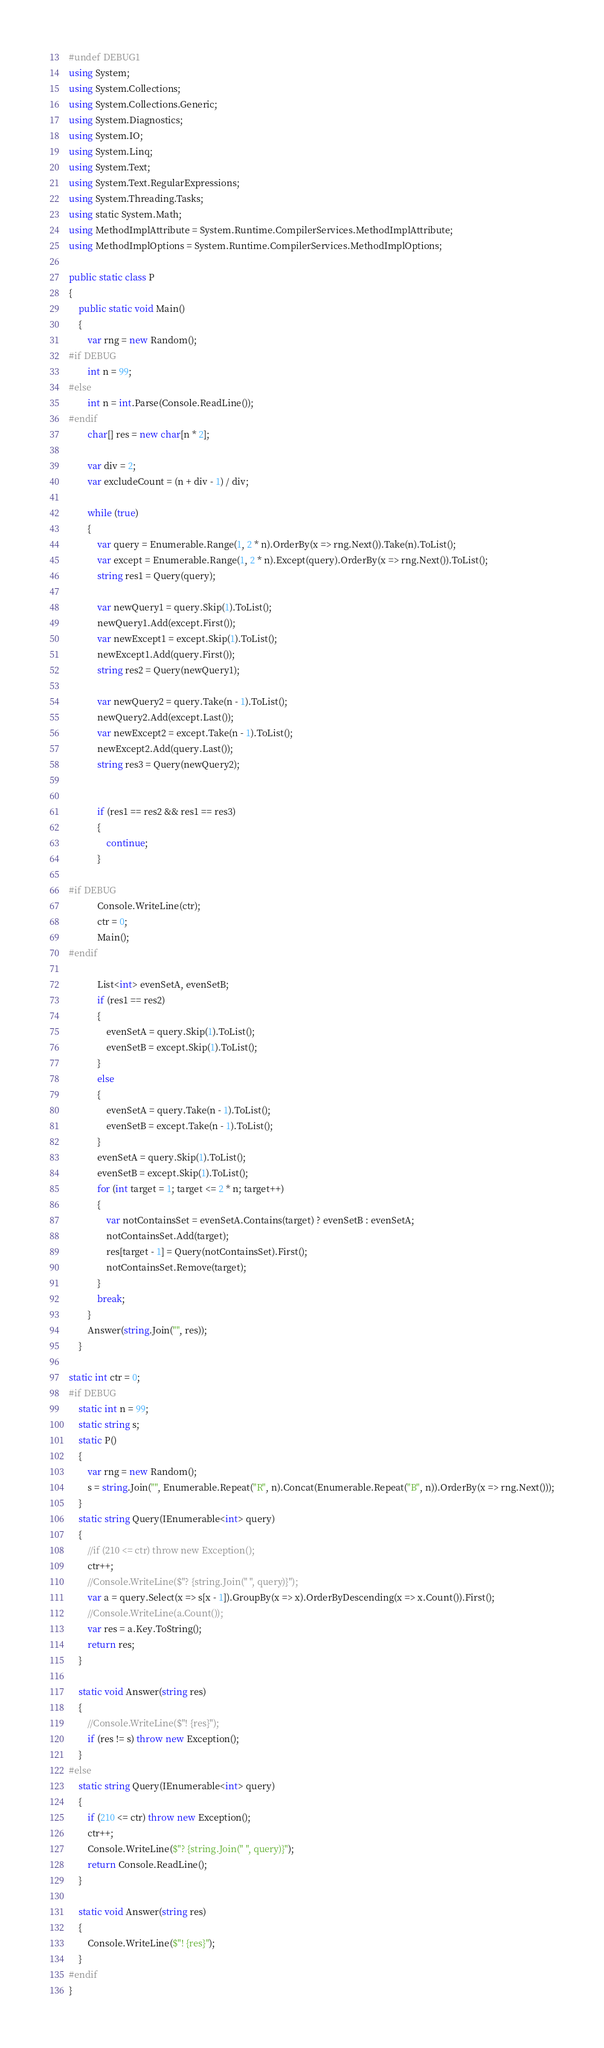<code> <loc_0><loc_0><loc_500><loc_500><_C#_>#undef DEBUG1
using System;
using System.Collections;
using System.Collections.Generic;
using System.Diagnostics;
using System.IO;
using System.Linq;
using System.Text;
using System.Text.RegularExpressions;
using System.Threading.Tasks;
using static System.Math;
using MethodImplAttribute = System.Runtime.CompilerServices.MethodImplAttribute;
using MethodImplOptions = System.Runtime.CompilerServices.MethodImplOptions;

public static class P
{
    public static void Main()
    {
        var rng = new Random();
#if DEBUG
        int n = 99;
#else
        int n = int.Parse(Console.ReadLine());
#endif
        char[] res = new char[n * 2];

        var div = 2;
        var excludeCount = (n + div - 1) / div;

        while (true)
        {
            var query = Enumerable.Range(1, 2 * n).OrderBy(x => rng.Next()).Take(n).ToList();
            var except = Enumerable.Range(1, 2 * n).Except(query).OrderBy(x => rng.Next()).ToList();
            string res1 = Query(query);

            var newQuery1 = query.Skip(1).ToList();
            newQuery1.Add(except.First());
            var newExcept1 = except.Skip(1).ToList();
            newExcept1.Add(query.First());
            string res2 = Query(newQuery1);

            var newQuery2 = query.Take(n - 1).ToList();
            newQuery2.Add(except.Last());
            var newExcept2 = except.Take(n - 1).ToList();
            newExcept2.Add(query.Last());
            string res3 = Query(newQuery2);


            if (res1 == res2 && res1 == res3)
            {
                continue;
            }

#if DEBUG
            Console.WriteLine(ctr);
            ctr = 0;
            Main();
#endif

            List<int> evenSetA, evenSetB;
            if (res1 == res2)
            {
                evenSetA = query.Skip(1).ToList();
                evenSetB = except.Skip(1).ToList();
            }
            else
            {
                evenSetA = query.Take(n - 1).ToList();
                evenSetB = except.Take(n - 1).ToList();
            }
            evenSetA = query.Skip(1).ToList();
            evenSetB = except.Skip(1).ToList();
            for (int target = 1; target <= 2 * n; target++)
            {
                var notContainsSet = evenSetA.Contains(target) ? evenSetB : evenSetA;
                notContainsSet.Add(target);
                res[target - 1] = Query(notContainsSet).First();
                notContainsSet.Remove(target);
            }
            break;
        }
        Answer(string.Join("", res));
    }

static int ctr = 0;
#if DEBUG
    static int n = 99;
    static string s;
    static P()
    {
        var rng = new Random();
        s = string.Join("", Enumerable.Repeat("R", n).Concat(Enumerable.Repeat("B", n)).OrderBy(x => rng.Next()));
    }
    static string Query(IEnumerable<int> query)
    {
        //if (210 <= ctr) throw new Exception();
        ctr++;
        //Console.WriteLine($"? {string.Join(" ", query)}");
        var a = query.Select(x => s[x - 1]).GroupBy(x => x).OrderByDescending(x => x.Count()).First();
        //Console.WriteLine(a.Count());
        var res = a.Key.ToString();
        return res;
    }

    static void Answer(string res)
    {
        //Console.WriteLine($"! {res}");
        if (res != s) throw new Exception();
    }
#else
    static string Query(IEnumerable<int> query)
    {
        if (210 <= ctr) throw new Exception();
        ctr++;
        Console.WriteLine($"? {string.Join(" ", query)}");
        return Console.ReadLine();
    }

    static void Answer(string res)
    {
        Console.WriteLine($"! {res}");
    }
#endif
}
</code> 